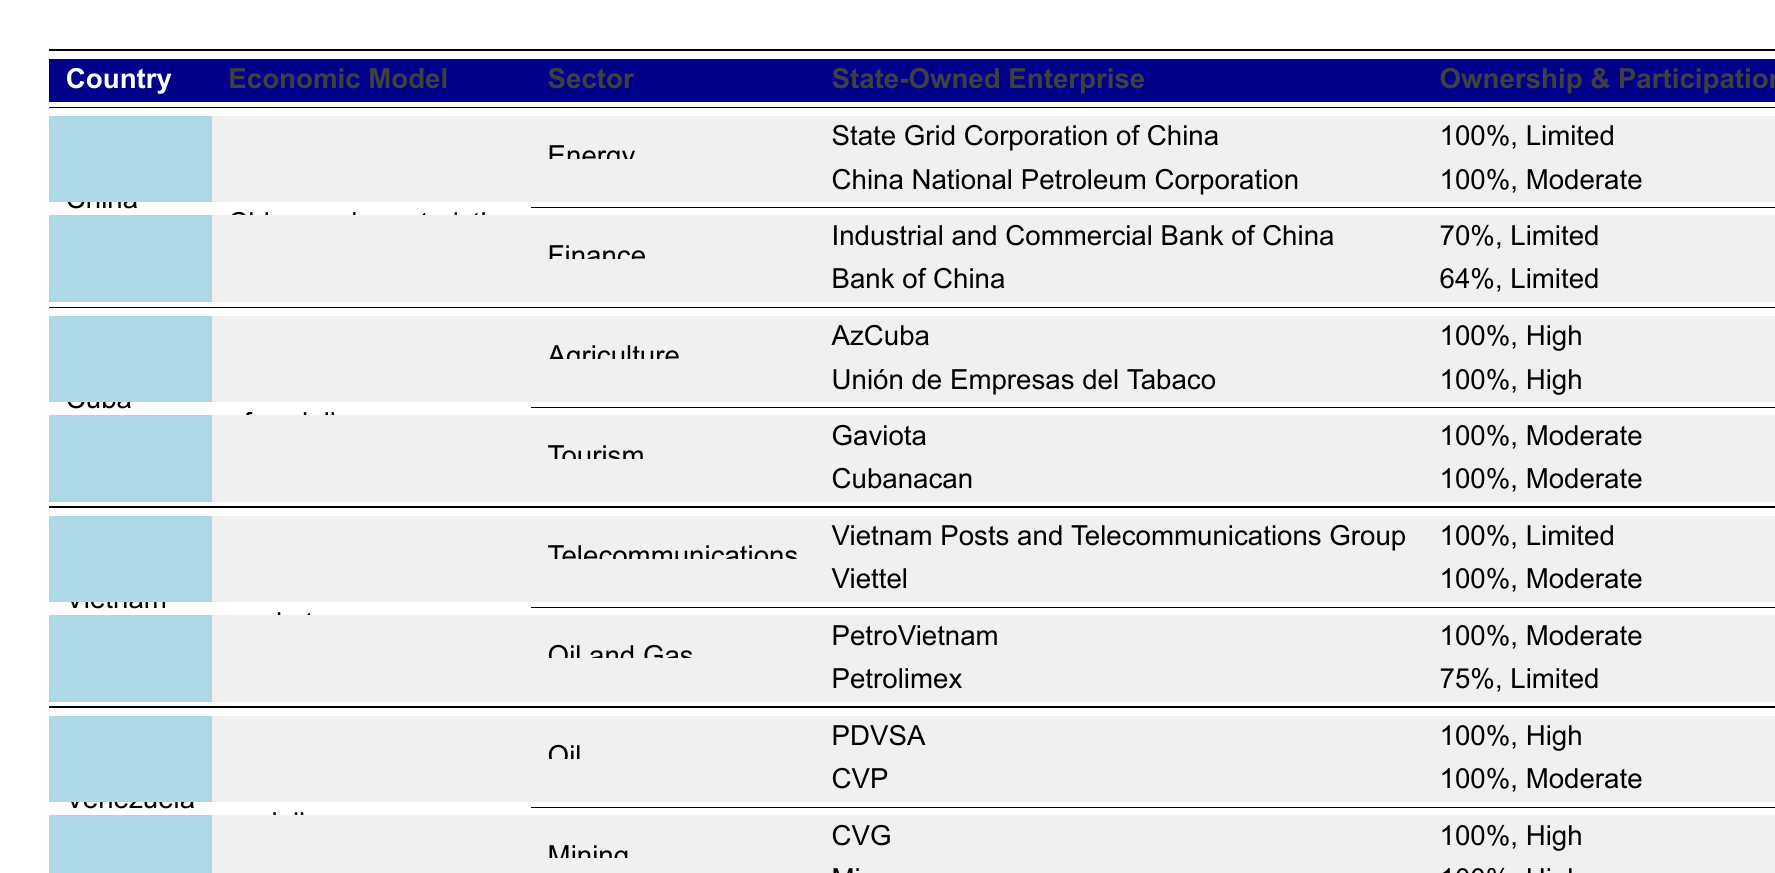What is the ownership percentage of the Bank of China? The table lists the Bank of China under the Finance sector for China with an ownership percentage of 64%.
Answer: 64% Which country has state-owned enterprises in the Mining sector? The table shows that Venezuela has state-owned enterprises in the Mining sector, specifically CVG and Minerven.
Answer: Venezuela What is the highest workers' participation level recorded in state-owned enterprises across the listed countries? Referring to the table, both Venezuela's PDVSA and CVG, as well as Cuba's AzCuba and Unión de Empresas del Tabaco, have a high level of workers' participation.
Answer: High How many different sectors are reported for Cuba? The table indicates that there are two sectors reported for Cuba: Agriculture and Tourism.
Answer: 2 Which country has the lowest ownership percentage in the finance sector? In the table, the Industrial and Commercial Bank of China has the lowest ownership percentage at 70% among the listed state-owned enterprises in the finance sector.
Answer: China (70%) How many state-owned enterprises in China have limited workers' participation? The table shows three state-owned enterprises in China with limited workers' participation: the State Grid Corporation, Industrial and Commercial Bank, and both Bank of China. Therefore, the answer is 3.
Answer: 3 Which socialist-inspired economy has 100% state-owned enterprises in both Agriculture and Oil sectors? According to the table, Cuba has 100% state-owned enterprises in the Agriculture sector (AzCuba and Unión de Empresas del Tabaco) and Venezuela has the same in the Oil sector (PDVSA and CVP).
Answer: Cuba (Agriculture) & Venezuela (Oil) What percentage of Vietnam's state-owned enterprises in Oil and Gas has workers' participation classified as moderate? The table lists PetroVietnam and Petrolimex in the Oil and Gas sector for Vietnam, with both having moderate workers' participation. Therefore, 100% of state-owned enterprises in this sector have moderate participation.
Answer: 100% Are there any sectors where all listed state-owned enterprises have high workers' participation? Referring to the table, both PDVSA and CVG from Venezuela's Oil and Mining sectors show high workers' participation, confirming that these sectors feature only enterprises with high involvement.
Answer: Yes What is the ratio of sectors to countries listed in the table for state-owned enterprises? The table lists 4 countries, each with 2 sectors, yielding 8 sectors total. The ratio of sectors to countries is 8:4, which simplifies to 2:1.
Answer: 2:1 